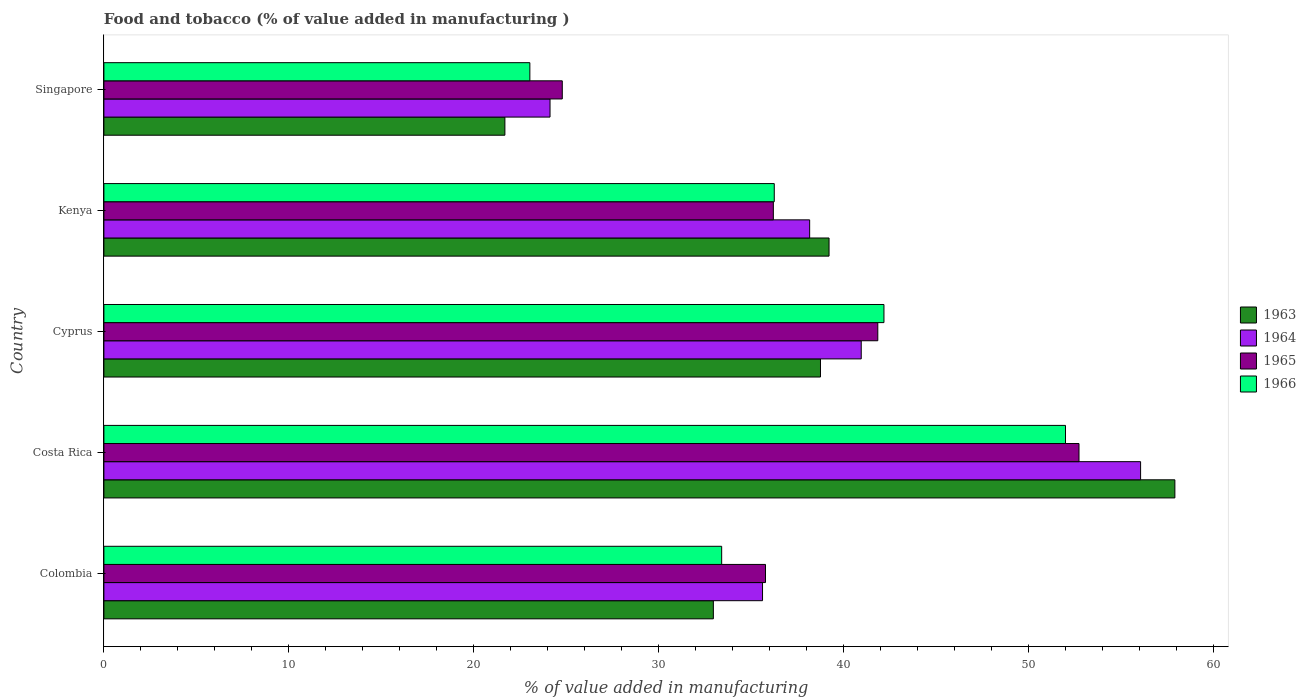How many groups of bars are there?
Ensure brevity in your answer.  5. What is the label of the 3rd group of bars from the top?
Ensure brevity in your answer.  Cyprus. What is the value added in manufacturing food and tobacco in 1966 in Singapore?
Give a very brief answer. 23.04. Across all countries, what is the maximum value added in manufacturing food and tobacco in 1963?
Ensure brevity in your answer.  57.92. Across all countries, what is the minimum value added in manufacturing food and tobacco in 1963?
Provide a short and direct response. 21.69. In which country was the value added in manufacturing food and tobacco in 1966 minimum?
Provide a succinct answer. Singapore. What is the total value added in manufacturing food and tobacco in 1966 in the graph?
Your answer should be very brief. 186.89. What is the difference between the value added in manufacturing food and tobacco in 1965 in Colombia and that in Kenya?
Give a very brief answer. -0.42. What is the difference between the value added in manufacturing food and tobacco in 1963 in Colombia and the value added in manufacturing food and tobacco in 1966 in Cyprus?
Your answer should be compact. -9.23. What is the average value added in manufacturing food and tobacco in 1963 per country?
Offer a very short reply. 38.11. What is the difference between the value added in manufacturing food and tobacco in 1964 and value added in manufacturing food and tobacco in 1963 in Costa Rica?
Keep it short and to the point. -1.85. In how many countries, is the value added in manufacturing food and tobacco in 1966 greater than 8 %?
Provide a short and direct response. 5. What is the ratio of the value added in manufacturing food and tobacco in 1963 in Costa Rica to that in Singapore?
Your response must be concise. 2.67. What is the difference between the highest and the second highest value added in manufacturing food and tobacco in 1966?
Give a very brief answer. 9.82. What is the difference between the highest and the lowest value added in manufacturing food and tobacco in 1965?
Offer a very short reply. 27.94. In how many countries, is the value added in manufacturing food and tobacco in 1965 greater than the average value added in manufacturing food and tobacco in 1965 taken over all countries?
Make the answer very short. 2. Is the sum of the value added in manufacturing food and tobacco in 1965 in Colombia and Cyprus greater than the maximum value added in manufacturing food and tobacco in 1963 across all countries?
Your answer should be very brief. Yes. Is it the case that in every country, the sum of the value added in manufacturing food and tobacco in 1966 and value added in manufacturing food and tobacco in 1964 is greater than the sum of value added in manufacturing food and tobacco in 1963 and value added in manufacturing food and tobacco in 1965?
Give a very brief answer. No. What does the 1st bar from the top in Colombia represents?
Your response must be concise. 1966. What does the 3rd bar from the bottom in Cyprus represents?
Provide a short and direct response. 1965. How many bars are there?
Your answer should be compact. 20. How many countries are there in the graph?
Your response must be concise. 5. Does the graph contain any zero values?
Offer a very short reply. No. Does the graph contain grids?
Give a very brief answer. No. How are the legend labels stacked?
Your answer should be very brief. Vertical. What is the title of the graph?
Give a very brief answer. Food and tobacco (% of value added in manufacturing ). What is the label or title of the X-axis?
Make the answer very short. % of value added in manufacturing. What is the label or title of the Y-axis?
Offer a very short reply. Country. What is the % of value added in manufacturing in 1963 in Colombia?
Your response must be concise. 32.96. What is the % of value added in manufacturing in 1964 in Colombia?
Make the answer very short. 35.62. What is the % of value added in manufacturing of 1965 in Colombia?
Your response must be concise. 35.78. What is the % of value added in manufacturing of 1966 in Colombia?
Offer a terse response. 33.41. What is the % of value added in manufacturing in 1963 in Costa Rica?
Provide a succinct answer. 57.92. What is the % of value added in manufacturing in 1964 in Costa Rica?
Keep it short and to the point. 56.07. What is the % of value added in manufacturing of 1965 in Costa Rica?
Keep it short and to the point. 52.73. What is the % of value added in manufacturing in 1966 in Costa Rica?
Ensure brevity in your answer.  52. What is the % of value added in manufacturing of 1963 in Cyprus?
Your answer should be very brief. 38.75. What is the % of value added in manufacturing of 1964 in Cyprus?
Your answer should be compact. 40.96. What is the % of value added in manufacturing in 1965 in Cyprus?
Provide a succinct answer. 41.85. What is the % of value added in manufacturing of 1966 in Cyprus?
Your answer should be compact. 42.19. What is the % of value added in manufacturing in 1963 in Kenya?
Keep it short and to the point. 39.22. What is the % of value added in manufacturing in 1964 in Kenya?
Keep it short and to the point. 38.17. What is the % of value added in manufacturing in 1965 in Kenya?
Your response must be concise. 36.2. What is the % of value added in manufacturing in 1966 in Kenya?
Your answer should be very brief. 36.25. What is the % of value added in manufacturing of 1963 in Singapore?
Provide a short and direct response. 21.69. What is the % of value added in manufacturing of 1964 in Singapore?
Your answer should be very brief. 24.13. What is the % of value added in manufacturing of 1965 in Singapore?
Offer a terse response. 24.79. What is the % of value added in manufacturing in 1966 in Singapore?
Provide a succinct answer. 23.04. Across all countries, what is the maximum % of value added in manufacturing in 1963?
Keep it short and to the point. 57.92. Across all countries, what is the maximum % of value added in manufacturing in 1964?
Provide a succinct answer. 56.07. Across all countries, what is the maximum % of value added in manufacturing of 1965?
Keep it short and to the point. 52.73. Across all countries, what is the maximum % of value added in manufacturing of 1966?
Provide a succinct answer. 52. Across all countries, what is the minimum % of value added in manufacturing in 1963?
Provide a short and direct response. 21.69. Across all countries, what is the minimum % of value added in manufacturing in 1964?
Offer a very short reply. 24.13. Across all countries, what is the minimum % of value added in manufacturing of 1965?
Make the answer very short. 24.79. Across all countries, what is the minimum % of value added in manufacturing of 1966?
Your answer should be very brief. 23.04. What is the total % of value added in manufacturing in 1963 in the graph?
Give a very brief answer. 190.54. What is the total % of value added in manufacturing of 1964 in the graph?
Your answer should be compact. 194.94. What is the total % of value added in manufacturing in 1965 in the graph?
Provide a short and direct response. 191.36. What is the total % of value added in manufacturing in 1966 in the graph?
Your answer should be compact. 186.89. What is the difference between the % of value added in manufacturing of 1963 in Colombia and that in Costa Rica?
Offer a terse response. -24.96. What is the difference between the % of value added in manufacturing of 1964 in Colombia and that in Costa Rica?
Make the answer very short. -20.45. What is the difference between the % of value added in manufacturing of 1965 in Colombia and that in Costa Rica?
Your answer should be very brief. -16.95. What is the difference between the % of value added in manufacturing of 1966 in Colombia and that in Costa Rica?
Provide a short and direct response. -18.59. What is the difference between the % of value added in manufacturing of 1963 in Colombia and that in Cyprus?
Give a very brief answer. -5.79. What is the difference between the % of value added in manufacturing of 1964 in Colombia and that in Cyprus?
Offer a terse response. -5.34. What is the difference between the % of value added in manufacturing of 1965 in Colombia and that in Cyprus?
Provide a succinct answer. -6.07. What is the difference between the % of value added in manufacturing of 1966 in Colombia and that in Cyprus?
Provide a succinct answer. -8.78. What is the difference between the % of value added in manufacturing of 1963 in Colombia and that in Kenya?
Your answer should be very brief. -6.26. What is the difference between the % of value added in manufacturing of 1964 in Colombia and that in Kenya?
Ensure brevity in your answer.  -2.55. What is the difference between the % of value added in manufacturing in 1965 in Colombia and that in Kenya?
Provide a short and direct response. -0.42. What is the difference between the % of value added in manufacturing in 1966 in Colombia and that in Kenya?
Your answer should be compact. -2.84. What is the difference between the % of value added in manufacturing in 1963 in Colombia and that in Singapore?
Your answer should be compact. 11.27. What is the difference between the % of value added in manufacturing of 1964 in Colombia and that in Singapore?
Provide a succinct answer. 11.49. What is the difference between the % of value added in manufacturing in 1965 in Colombia and that in Singapore?
Your answer should be compact. 10.99. What is the difference between the % of value added in manufacturing of 1966 in Colombia and that in Singapore?
Offer a terse response. 10.37. What is the difference between the % of value added in manufacturing of 1963 in Costa Rica and that in Cyprus?
Provide a succinct answer. 19.17. What is the difference between the % of value added in manufacturing in 1964 in Costa Rica and that in Cyprus?
Your answer should be very brief. 15.11. What is the difference between the % of value added in manufacturing in 1965 in Costa Rica and that in Cyprus?
Offer a very short reply. 10.88. What is the difference between the % of value added in manufacturing in 1966 in Costa Rica and that in Cyprus?
Provide a short and direct response. 9.82. What is the difference between the % of value added in manufacturing in 1963 in Costa Rica and that in Kenya?
Give a very brief answer. 18.7. What is the difference between the % of value added in manufacturing of 1964 in Costa Rica and that in Kenya?
Make the answer very short. 17.9. What is the difference between the % of value added in manufacturing of 1965 in Costa Rica and that in Kenya?
Your answer should be very brief. 16.53. What is the difference between the % of value added in manufacturing of 1966 in Costa Rica and that in Kenya?
Provide a short and direct response. 15.75. What is the difference between the % of value added in manufacturing in 1963 in Costa Rica and that in Singapore?
Offer a very short reply. 36.23. What is the difference between the % of value added in manufacturing of 1964 in Costa Rica and that in Singapore?
Your answer should be very brief. 31.94. What is the difference between the % of value added in manufacturing of 1965 in Costa Rica and that in Singapore?
Give a very brief answer. 27.94. What is the difference between the % of value added in manufacturing of 1966 in Costa Rica and that in Singapore?
Offer a terse response. 28.97. What is the difference between the % of value added in manufacturing of 1963 in Cyprus and that in Kenya?
Your answer should be compact. -0.46. What is the difference between the % of value added in manufacturing of 1964 in Cyprus and that in Kenya?
Give a very brief answer. 2.79. What is the difference between the % of value added in manufacturing in 1965 in Cyprus and that in Kenya?
Your answer should be compact. 5.65. What is the difference between the % of value added in manufacturing of 1966 in Cyprus and that in Kenya?
Your answer should be very brief. 5.93. What is the difference between the % of value added in manufacturing of 1963 in Cyprus and that in Singapore?
Provide a short and direct response. 17.07. What is the difference between the % of value added in manufacturing of 1964 in Cyprus and that in Singapore?
Your response must be concise. 16.83. What is the difference between the % of value added in manufacturing of 1965 in Cyprus and that in Singapore?
Offer a terse response. 17.06. What is the difference between the % of value added in manufacturing of 1966 in Cyprus and that in Singapore?
Make the answer very short. 19.15. What is the difference between the % of value added in manufacturing of 1963 in Kenya and that in Singapore?
Give a very brief answer. 17.53. What is the difference between the % of value added in manufacturing in 1964 in Kenya and that in Singapore?
Provide a short and direct response. 14.04. What is the difference between the % of value added in manufacturing of 1965 in Kenya and that in Singapore?
Keep it short and to the point. 11.41. What is the difference between the % of value added in manufacturing of 1966 in Kenya and that in Singapore?
Give a very brief answer. 13.22. What is the difference between the % of value added in manufacturing of 1963 in Colombia and the % of value added in manufacturing of 1964 in Costa Rica?
Provide a short and direct response. -23.11. What is the difference between the % of value added in manufacturing of 1963 in Colombia and the % of value added in manufacturing of 1965 in Costa Rica?
Ensure brevity in your answer.  -19.77. What is the difference between the % of value added in manufacturing of 1963 in Colombia and the % of value added in manufacturing of 1966 in Costa Rica?
Make the answer very short. -19.04. What is the difference between the % of value added in manufacturing of 1964 in Colombia and the % of value added in manufacturing of 1965 in Costa Rica?
Provide a succinct answer. -17.11. What is the difference between the % of value added in manufacturing in 1964 in Colombia and the % of value added in manufacturing in 1966 in Costa Rica?
Your response must be concise. -16.38. What is the difference between the % of value added in manufacturing in 1965 in Colombia and the % of value added in manufacturing in 1966 in Costa Rica?
Your response must be concise. -16.22. What is the difference between the % of value added in manufacturing of 1963 in Colombia and the % of value added in manufacturing of 1964 in Cyprus?
Ensure brevity in your answer.  -8. What is the difference between the % of value added in manufacturing of 1963 in Colombia and the % of value added in manufacturing of 1965 in Cyprus?
Your answer should be compact. -8.89. What is the difference between the % of value added in manufacturing of 1963 in Colombia and the % of value added in manufacturing of 1966 in Cyprus?
Give a very brief answer. -9.23. What is the difference between the % of value added in manufacturing of 1964 in Colombia and the % of value added in manufacturing of 1965 in Cyprus?
Keep it short and to the point. -6.23. What is the difference between the % of value added in manufacturing of 1964 in Colombia and the % of value added in manufacturing of 1966 in Cyprus?
Offer a terse response. -6.57. What is the difference between the % of value added in manufacturing in 1965 in Colombia and the % of value added in manufacturing in 1966 in Cyprus?
Ensure brevity in your answer.  -6.41. What is the difference between the % of value added in manufacturing in 1963 in Colombia and the % of value added in manufacturing in 1964 in Kenya?
Provide a short and direct response. -5.21. What is the difference between the % of value added in manufacturing of 1963 in Colombia and the % of value added in manufacturing of 1965 in Kenya?
Offer a very short reply. -3.24. What is the difference between the % of value added in manufacturing of 1963 in Colombia and the % of value added in manufacturing of 1966 in Kenya?
Your answer should be compact. -3.29. What is the difference between the % of value added in manufacturing of 1964 in Colombia and the % of value added in manufacturing of 1965 in Kenya?
Provide a short and direct response. -0.58. What is the difference between the % of value added in manufacturing in 1964 in Colombia and the % of value added in manufacturing in 1966 in Kenya?
Your answer should be very brief. -0.63. What is the difference between the % of value added in manufacturing of 1965 in Colombia and the % of value added in manufacturing of 1966 in Kenya?
Your answer should be very brief. -0.47. What is the difference between the % of value added in manufacturing of 1963 in Colombia and the % of value added in manufacturing of 1964 in Singapore?
Offer a terse response. 8.83. What is the difference between the % of value added in manufacturing of 1963 in Colombia and the % of value added in manufacturing of 1965 in Singapore?
Your answer should be compact. 8.17. What is the difference between the % of value added in manufacturing of 1963 in Colombia and the % of value added in manufacturing of 1966 in Singapore?
Keep it short and to the point. 9.92. What is the difference between the % of value added in manufacturing of 1964 in Colombia and the % of value added in manufacturing of 1965 in Singapore?
Ensure brevity in your answer.  10.83. What is the difference between the % of value added in manufacturing of 1964 in Colombia and the % of value added in manufacturing of 1966 in Singapore?
Your response must be concise. 12.58. What is the difference between the % of value added in manufacturing in 1965 in Colombia and the % of value added in manufacturing in 1966 in Singapore?
Your response must be concise. 12.74. What is the difference between the % of value added in manufacturing of 1963 in Costa Rica and the % of value added in manufacturing of 1964 in Cyprus?
Your answer should be compact. 16.96. What is the difference between the % of value added in manufacturing in 1963 in Costa Rica and the % of value added in manufacturing in 1965 in Cyprus?
Provide a succinct answer. 16.07. What is the difference between the % of value added in manufacturing in 1963 in Costa Rica and the % of value added in manufacturing in 1966 in Cyprus?
Ensure brevity in your answer.  15.73. What is the difference between the % of value added in manufacturing in 1964 in Costa Rica and the % of value added in manufacturing in 1965 in Cyprus?
Ensure brevity in your answer.  14.21. What is the difference between the % of value added in manufacturing in 1964 in Costa Rica and the % of value added in manufacturing in 1966 in Cyprus?
Offer a very short reply. 13.88. What is the difference between the % of value added in manufacturing in 1965 in Costa Rica and the % of value added in manufacturing in 1966 in Cyprus?
Offer a terse response. 10.55. What is the difference between the % of value added in manufacturing in 1963 in Costa Rica and the % of value added in manufacturing in 1964 in Kenya?
Offer a terse response. 19.75. What is the difference between the % of value added in manufacturing of 1963 in Costa Rica and the % of value added in manufacturing of 1965 in Kenya?
Provide a succinct answer. 21.72. What is the difference between the % of value added in manufacturing in 1963 in Costa Rica and the % of value added in manufacturing in 1966 in Kenya?
Provide a short and direct response. 21.67. What is the difference between the % of value added in manufacturing in 1964 in Costa Rica and the % of value added in manufacturing in 1965 in Kenya?
Provide a short and direct response. 19.86. What is the difference between the % of value added in manufacturing of 1964 in Costa Rica and the % of value added in manufacturing of 1966 in Kenya?
Ensure brevity in your answer.  19.81. What is the difference between the % of value added in manufacturing of 1965 in Costa Rica and the % of value added in manufacturing of 1966 in Kenya?
Offer a very short reply. 16.48. What is the difference between the % of value added in manufacturing of 1963 in Costa Rica and the % of value added in manufacturing of 1964 in Singapore?
Your answer should be very brief. 33.79. What is the difference between the % of value added in manufacturing of 1963 in Costa Rica and the % of value added in manufacturing of 1965 in Singapore?
Your answer should be very brief. 33.13. What is the difference between the % of value added in manufacturing in 1963 in Costa Rica and the % of value added in manufacturing in 1966 in Singapore?
Provide a succinct answer. 34.88. What is the difference between the % of value added in manufacturing of 1964 in Costa Rica and the % of value added in manufacturing of 1965 in Singapore?
Your answer should be compact. 31.28. What is the difference between the % of value added in manufacturing of 1964 in Costa Rica and the % of value added in manufacturing of 1966 in Singapore?
Your response must be concise. 33.03. What is the difference between the % of value added in manufacturing in 1965 in Costa Rica and the % of value added in manufacturing in 1966 in Singapore?
Your answer should be compact. 29.7. What is the difference between the % of value added in manufacturing of 1963 in Cyprus and the % of value added in manufacturing of 1964 in Kenya?
Offer a terse response. 0.59. What is the difference between the % of value added in manufacturing in 1963 in Cyprus and the % of value added in manufacturing in 1965 in Kenya?
Give a very brief answer. 2.55. What is the difference between the % of value added in manufacturing in 1963 in Cyprus and the % of value added in manufacturing in 1966 in Kenya?
Ensure brevity in your answer.  2.5. What is the difference between the % of value added in manufacturing of 1964 in Cyprus and the % of value added in manufacturing of 1965 in Kenya?
Provide a short and direct response. 4.75. What is the difference between the % of value added in manufacturing in 1964 in Cyprus and the % of value added in manufacturing in 1966 in Kenya?
Provide a short and direct response. 4.7. What is the difference between the % of value added in manufacturing of 1965 in Cyprus and the % of value added in manufacturing of 1966 in Kenya?
Make the answer very short. 5.6. What is the difference between the % of value added in manufacturing of 1963 in Cyprus and the % of value added in manufacturing of 1964 in Singapore?
Give a very brief answer. 14.63. What is the difference between the % of value added in manufacturing in 1963 in Cyprus and the % of value added in manufacturing in 1965 in Singapore?
Your response must be concise. 13.96. What is the difference between the % of value added in manufacturing in 1963 in Cyprus and the % of value added in manufacturing in 1966 in Singapore?
Give a very brief answer. 15.72. What is the difference between the % of value added in manufacturing in 1964 in Cyprus and the % of value added in manufacturing in 1965 in Singapore?
Provide a succinct answer. 16.17. What is the difference between the % of value added in manufacturing in 1964 in Cyprus and the % of value added in manufacturing in 1966 in Singapore?
Ensure brevity in your answer.  17.92. What is the difference between the % of value added in manufacturing in 1965 in Cyprus and the % of value added in manufacturing in 1966 in Singapore?
Offer a terse response. 18.82. What is the difference between the % of value added in manufacturing in 1963 in Kenya and the % of value added in manufacturing in 1964 in Singapore?
Keep it short and to the point. 15.09. What is the difference between the % of value added in manufacturing in 1963 in Kenya and the % of value added in manufacturing in 1965 in Singapore?
Provide a succinct answer. 14.43. What is the difference between the % of value added in manufacturing of 1963 in Kenya and the % of value added in manufacturing of 1966 in Singapore?
Offer a terse response. 16.18. What is the difference between the % of value added in manufacturing of 1964 in Kenya and the % of value added in manufacturing of 1965 in Singapore?
Your response must be concise. 13.38. What is the difference between the % of value added in manufacturing of 1964 in Kenya and the % of value added in manufacturing of 1966 in Singapore?
Your answer should be very brief. 15.13. What is the difference between the % of value added in manufacturing of 1965 in Kenya and the % of value added in manufacturing of 1966 in Singapore?
Make the answer very short. 13.17. What is the average % of value added in manufacturing in 1963 per country?
Your response must be concise. 38.11. What is the average % of value added in manufacturing in 1964 per country?
Your answer should be compact. 38.99. What is the average % of value added in manufacturing in 1965 per country?
Provide a short and direct response. 38.27. What is the average % of value added in manufacturing in 1966 per country?
Make the answer very short. 37.38. What is the difference between the % of value added in manufacturing in 1963 and % of value added in manufacturing in 1964 in Colombia?
Offer a very short reply. -2.66. What is the difference between the % of value added in manufacturing of 1963 and % of value added in manufacturing of 1965 in Colombia?
Give a very brief answer. -2.82. What is the difference between the % of value added in manufacturing in 1963 and % of value added in manufacturing in 1966 in Colombia?
Offer a very short reply. -0.45. What is the difference between the % of value added in manufacturing in 1964 and % of value added in manufacturing in 1965 in Colombia?
Make the answer very short. -0.16. What is the difference between the % of value added in manufacturing of 1964 and % of value added in manufacturing of 1966 in Colombia?
Your answer should be very brief. 2.21. What is the difference between the % of value added in manufacturing of 1965 and % of value added in manufacturing of 1966 in Colombia?
Make the answer very short. 2.37. What is the difference between the % of value added in manufacturing in 1963 and % of value added in manufacturing in 1964 in Costa Rica?
Give a very brief answer. 1.85. What is the difference between the % of value added in manufacturing in 1963 and % of value added in manufacturing in 1965 in Costa Rica?
Your answer should be compact. 5.19. What is the difference between the % of value added in manufacturing in 1963 and % of value added in manufacturing in 1966 in Costa Rica?
Your answer should be compact. 5.92. What is the difference between the % of value added in manufacturing of 1964 and % of value added in manufacturing of 1965 in Costa Rica?
Give a very brief answer. 3.33. What is the difference between the % of value added in manufacturing in 1964 and % of value added in manufacturing in 1966 in Costa Rica?
Give a very brief answer. 4.06. What is the difference between the % of value added in manufacturing of 1965 and % of value added in manufacturing of 1966 in Costa Rica?
Your answer should be very brief. 0.73. What is the difference between the % of value added in manufacturing in 1963 and % of value added in manufacturing in 1964 in Cyprus?
Your response must be concise. -2.2. What is the difference between the % of value added in manufacturing in 1963 and % of value added in manufacturing in 1965 in Cyprus?
Give a very brief answer. -3.1. What is the difference between the % of value added in manufacturing in 1963 and % of value added in manufacturing in 1966 in Cyprus?
Your answer should be very brief. -3.43. What is the difference between the % of value added in manufacturing in 1964 and % of value added in manufacturing in 1965 in Cyprus?
Offer a terse response. -0.9. What is the difference between the % of value added in manufacturing in 1964 and % of value added in manufacturing in 1966 in Cyprus?
Your answer should be very brief. -1.23. What is the difference between the % of value added in manufacturing in 1965 and % of value added in manufacturing in 1966 in Cyprus?
Keep it short and to the point. -0.33. What is the difference between the % of value added in manufacturing in 1963 and % of value added in manufacturing in 1964 in Kenya?
Provide a short and direct response. 1.05. What is the difference between the % of value added in manufacturing in 1963 and % of value added in manufacturing in 1965 in Kenya?
Your answer should be very brief. 3.01. What is the difference between the % of value added in manufacturing in 1963 and % of value added in manufacturing in 1966 in Kenya?
Your answer should be very brief. 2.96. What is the difference between the % of value added in manufacturing in 1964 and % of value added in manufacturing in 1965 in Kenya?
Offer a very short reply. 1.96. What is the difference between the % of value added in manufacturing of 1964 and % of value added in manufacturing of 1966 in Kenya?
Provide a short and direct response. 1.91. What is the difference between the % of value added in manufacturing in 1965 and % of value added in manufacturing in 1966 in Kenya?
Provide a succinct answer. -0.05. What is the difference between the % of value added in manufacturing in 1963 and % of value added in manufacturing in 1964 in Singapore?
Keep it short and to the point. -2.44. What is the difference between the % of value added in manufacturing in 1963 and % of value added in manufacturing in 1965 in Singapore?
Offer a terse response. -3.1. What is the difference between the % of value added in manufacturing of 1963 and % of value added in manufacturing of 1966 in Singapore?
Offer a very short reply. -1.35. What is the difference between the % of value added in manufacturing of 1964 and % of value added in manufacturing of 1965 in Singapore?
Provide a succinct answer. -0.66. What is the difference between the % of value added in manufacturing in 1964 and % of value added in manufacturing in 1966 in Singapore?
Your response must be concise. 1.09. What is the difference between the % of value added in manufacturing in 1965 and % of value added in manufacturing in 1966 in Singapore?
Provide a succinct answer. 1.75. What is the ratio of the % of value added in manufacturing of 1963 in Colombia to that in Costa Rica?
Offer a very short reply. 0.57. What is the ratio of the % of value added in manufacturing of 1964 in Colombia to that in Costa Rica?
Give a very brief answer. 0.64. What is the ratio of the % of value added in manufacturing in 1965 in Colombia to that in Costa Rica?
Your answer should be very brief. 0.68. What is the ratio of the % of value added in manufacturing of 1966 in Colombia to that in Costa Rica?
Give a very brief answer. 0.64. What is the ratio of the % of value added in manufacturing of 1963 in Colombia to that in Cyprus?
Your answer should be compact. 0.85. What is the ratio of the % of value added in manufacturing in 1964 in Colombia to that in Cyprus?
Your response must be concise. 0.87. What is the ratio of the % of value added in manufacturing of 1965 in Colombia to that in Cyprus?
Your answer should be compact. 0.85. What is the ratio of the % of value added in manufacturing in 1966 in Colombia to that in Cyprus?
Your response must be concise. 0.79. What is the ratio of the % of value added in manufacturing in 1963 in Colombia to that in Kenya?
Provide a short and direct response. 0.84. What is the ratio of the % of value added in manufacturing in 1964 in Colombia to that in Kenya?
Provide a succinct answer. 0.93. What is the ratio of the % of value added in manufacturing of 1965 in Colombia to that in Kenya?
Offer a terse response. 0.99. What is the ratio of the % of value added in manufacturing of 1966 in Colombia to that in Kenya?
Give a very brief answer. 0.92. What is the ratio of the % of value added in manufacturing in 1963 in Colombia to that in Singapore?
Your answer should be compact. 1.52. What is the ratio of the % of value added in manufacturing in 1964 in Colombia to that in Singapore?
Provide a succinct answer. 1.48. What is the ratio of the % of value added in manufacturing in 1965 in Colombia to that in Singapore?
Give a very brief answer. 1.44. What is the ratio of the % of value added in manufacturing in 1966 in Colombia to that in Singapore?
Your answer should be compact. 1.45. What is the ratio of the % of value added in manufacturing in 1963 in Costa Rica to that in Cyprus?
Offer a terse response. 1.49. What is the ratio of the % of value added in manufacturing in 1964 in Costa Rica to that in Cyprus?
Ensure brevity in your answer.  1.37. What is the ratio of the % of value added in manufacturing in 1965 in Costa Rica to that in Cyprus?
Your answer should be very brief. 1.26. What is the ratio of the % of value added in manufacturing in 1966 in Costa Rica to that in Cyprus?
Provide a short and direct response. 1.23. What is the ratio of the % of value added in manufacturing in 1963 in Costa Rica to that in Kenya?
Your answer should be compact. 1.48. What is the ratio of the % of value added in manufacturing in 1964 in Costa Rica to that in Kenya?
Make the answer very short. 1.47. What is the ratio of the % of value added in manufacturing in 1965 in Costa Rica to that in Kenya?
Offer a very short reply. 1.46. What is the ratio of the % of value added in manufacturing in 1966 in Costa Rica to that in Kenya?
Your answer should be very brief. 1.43. What is the ratio of the % of value added in manufacturing of 1963 in Costa Rica to that in Singapore?
Your response must be concise. 2.67. What is the ratio of the % of value added in manufacturing of 1964 in Costa Rica to that in Singapore?
Provide a succinct answer. 2.32. What is the ratio of the % of value added in manufacturing of 1965 in Costa Rica to that in Singapore?
Provide a short and direct response. 2.13. What is the ratio of the % of value added in manufacturing of 1966 in Costa Rica to that in Singapore?
Keep it short and to the point. 2.26. What is the ratio of the % of value added in manufacturing of 1963 in Cyprus to that in Kenya?
Provide a short and direct response. 0.99. What is the ratio of the % of value added in manufacturing in 1964 in Cyprus to that in Kenya?
Offer a terse response. 1.07. What is the ratio of the % of value added in manufacturing of 1965 in Cyprus to that in Kenya?
Give a very brief answer. 1.16. What is the ratio of the % of value added in manufacturing of 1966 in Cyprus to that in Kenya?
Provide a short and direct response. 1.16. What is the ratio of the % of value added in manufacturing in 1963 in Cyprus to that in Singapore?
Keep it short and to the point. 1.79. What is the ratio of the % of value added in manufacturing in 1964 in Cyprus to that in Singapore?
Provide a succinct answer. 1.7. What is the ratio of the % of value added in manufacturing in 1965 in Cyprus to that in Singapore?
Offer a terse response. 1.69. What is the ratio of the % of value added in manufacturing in 1966 in Cyprus to that in Singapore?
Your answer should be very brief. 1.83. What is the ratio of the % of value added in manufacturing in 1963 in Kenya to that in Singapore?
Offer a terse response. 1.81. What is the ratio of the % of value added in manufacturing in 1964 in Kenya to that in Singapore?
Your response must be concise. 1.58. What is the ratio of the % of value added in manufacturing of 1965 in Kenya to that in Singapore?
Give a very brief answer. 1.46. What is the ratio of the % of value added in manufacturing of 1966 in Kenya to that in Singapore?
Make the answer very short. 1.57. What is the difference between the highest and the second highest % of value added in manufacturing in 1963?
Provide a short and direct response. 18.7. What is the difference between the highest and the second highest % of value added in manufacturing of 1964?
Offer a terse response. 15.11. What is the difference between the highest and the second highest % of value added in manufacturing of 1965?
Provide a short and direct response. 10.88. What is the difference between the highest and the second highest % of value added in manufacturing of 1966?
Offer a very short reply. 9.82. What is the difference between the highest and the lowest % of value added in manufacturing of 1963?
Your answer should be compact. 36.23. What is the difference between the highest and the lowest % of value added in manufacturing in 1964?
Your answer should be compact. 31.94. What is the difference between the highest and the lowest % of value added in manufacturing in 1965?
Your answer should be compact. 27.94. What is the difference between the highest and the lowest % of value added in manufacturing in 1966?
Give a very brief answer. 28.97. 